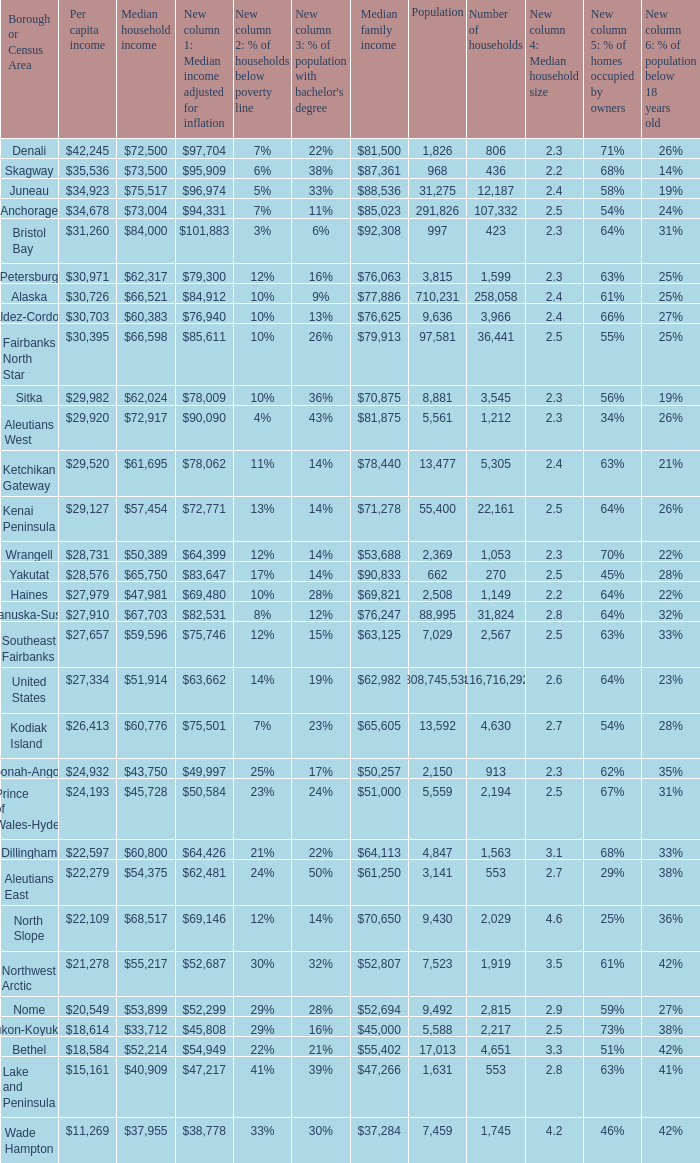What is the population of the area with a median family income of $71,278? 1.0. 